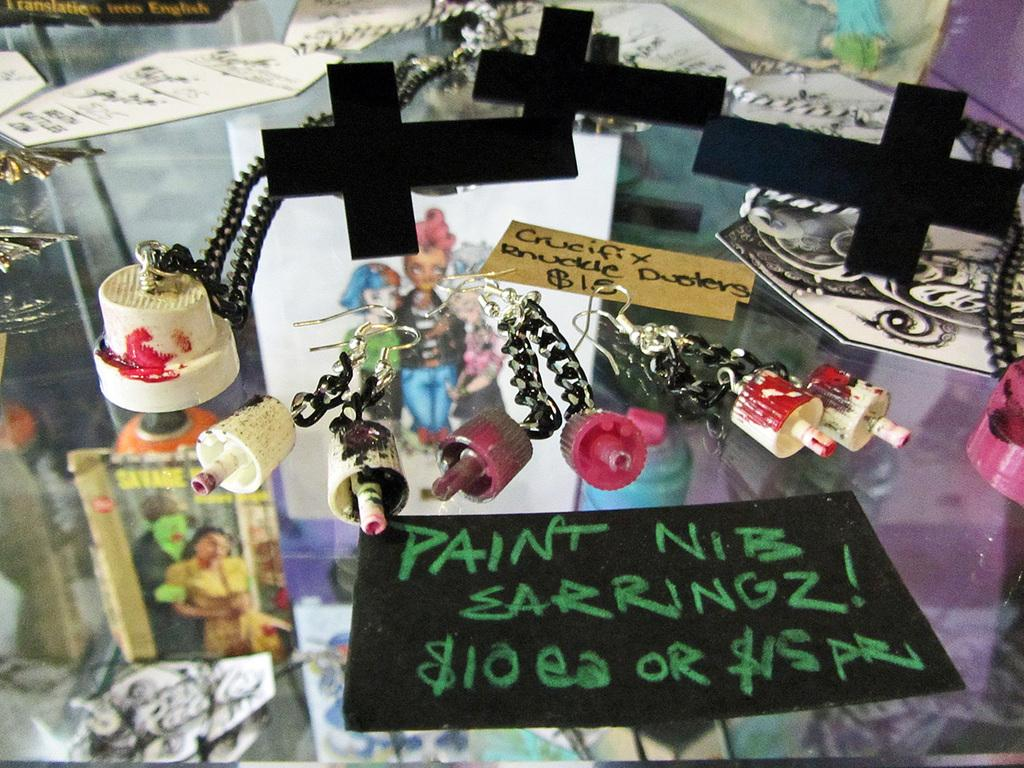What type of symbols can be seen in the image? There are cross symbols in the image. What else is present on the glass table? There are papers and key chains in the image. What material is the table made of? The objects are on a glass table. What type of roll can be seen in the image? There is no roll present in the image. What pump is used to inflate the key chains in the image? There is no pump present in the image, and key chains do not require inflation. 